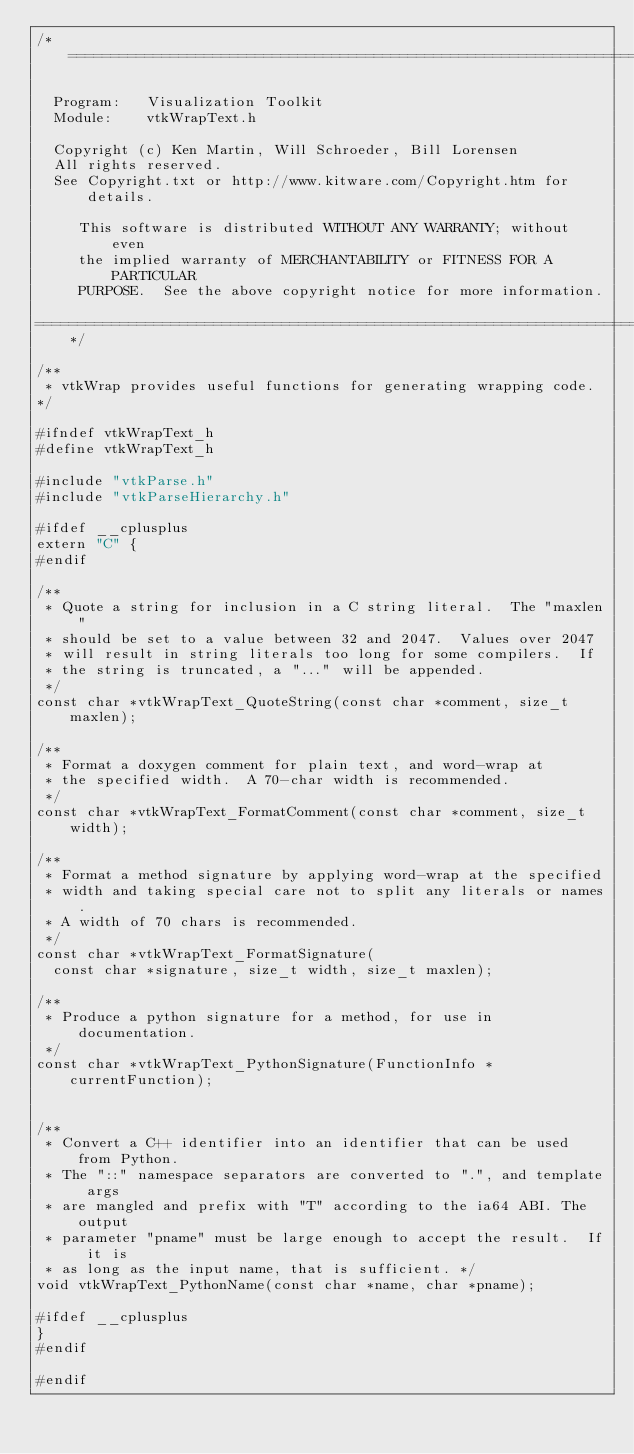<code> <loc_0><loc_0><loc_500><loc_500><_C_>/*=========================================================================

  Program:   Visualization Toolkit
  Module:    vtkWrapText.h

  Copyright (c) Ken Martin, Will Schroeder, Bill Lorensen
  All rights reserved.
  See Copyright.txt or http://www.kitware.com/Copyright.htm for details.

     This software is distributed WITHOUT ANY WARRANTY; without even
     the implied warranty of MERCHANTABILITY or FITNESS FOR A PARTICULAR
     PURPOSE.  See the above copyright notice for more information.

=========================================================================*/

/**
 * vtkWrap provides useful functions for generating wrapping code.
*/

#ifndef vtkWrapText_h
#define vtkWrapText_h

#include "vtkParse.h"
#include "vtkParseHierarchy.h"

#ifdef __cplusplus
extern "C" {
#endif

/**
 * Quote a string for inclusion in a C string literal.  The "maxlen"
 * should be set to a value between 32 and 2047.  Values over 2047
 * will result in string literals too long for some compilers.  If
 * the string is truncated, a "..." will be appended.
 */
const char *vtkWrapText_QuoteString(const char *comment, size_t maxlen);

/**
 * Format a doxygen comment for plain text, and word-wrap at
 * the specified width.  A 70-char width is recommended.
 */
const char *vtkWrapText_FormatComment(const char *comment, size_t width);

/**
 * Format a method signature by applying word-wrap at the specified
 * width and taking special care not to split any literals or names.
 * A width of 70 chars is recommended.
 */
const char *vtkWrapText_FormatSignature(
  const char *signature, size_t width, size_t maxlen);

/**
 * Produce a python signature for a method, for use in documentation.
 */
const char *vtkWrapText_PythonSignature(FunctionInfo *currentFunction);


/**
 * Convert a C++ identifier into an identifier that can be used from Python.
 * The "::" namespace separators are converted to ".", and template args
 * are mangled and prefix with "T" according to the ia64 ABI. The output
 * parameter "pname" must be large enough to accept the result.  If it is
 * as long as the input name, that is sufficient. */
void vtkWrapText_PythonName(const char *name, char *pname);

#ifdef __cplusplus
}
#endif

#endif
</code> 